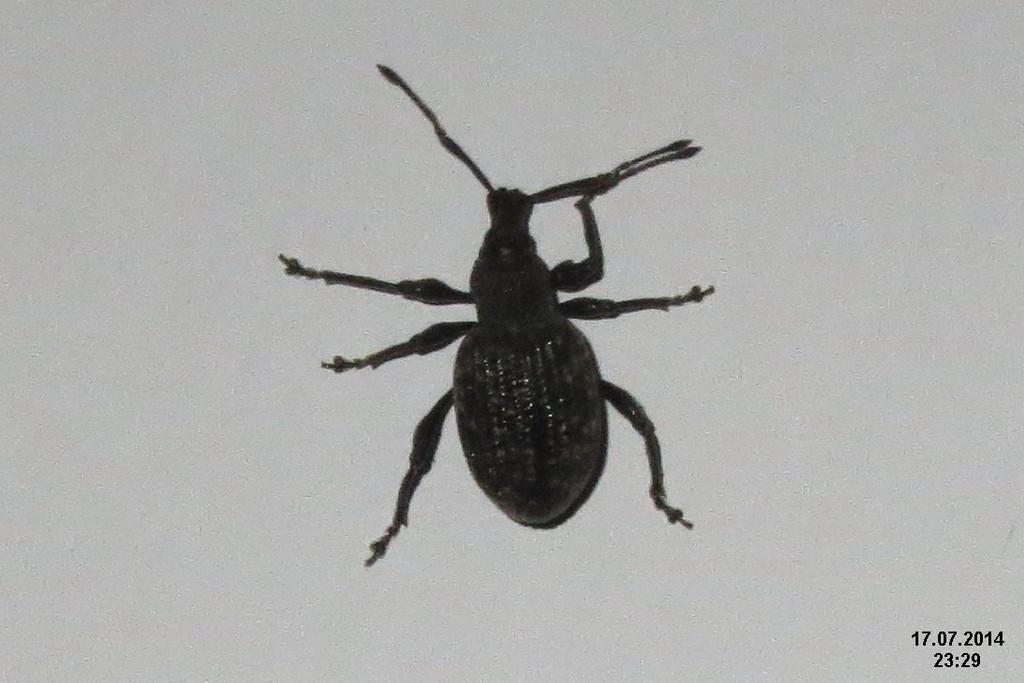How would you summarize this image in a sentence or two? In this picture we can see an insect on the surface. In the bottom right corner we can see the text. 